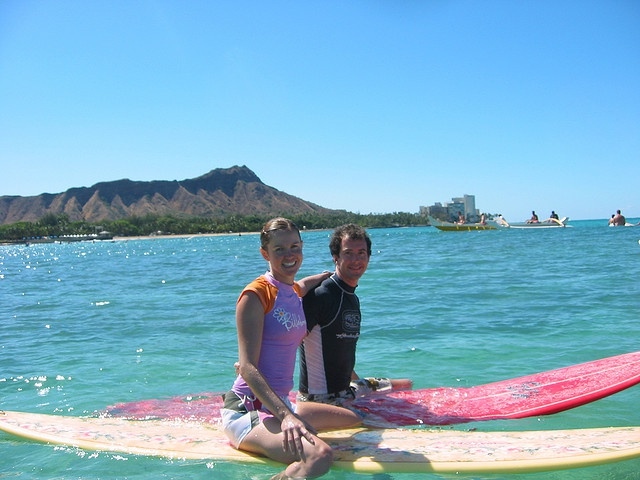Describe the objects in this image and their specific colors. I can see surfboard in lightblue, white, khaki, green, and gray tones, people in lightblue, gray, purple, and lavender tones, surfboard in lightblue, lightpink, salmon, and pink tones, people in lightblue, black, gray, and maroon tones, and boat in lightblue, gray, purple, black, and darkgreen tones in this image. 